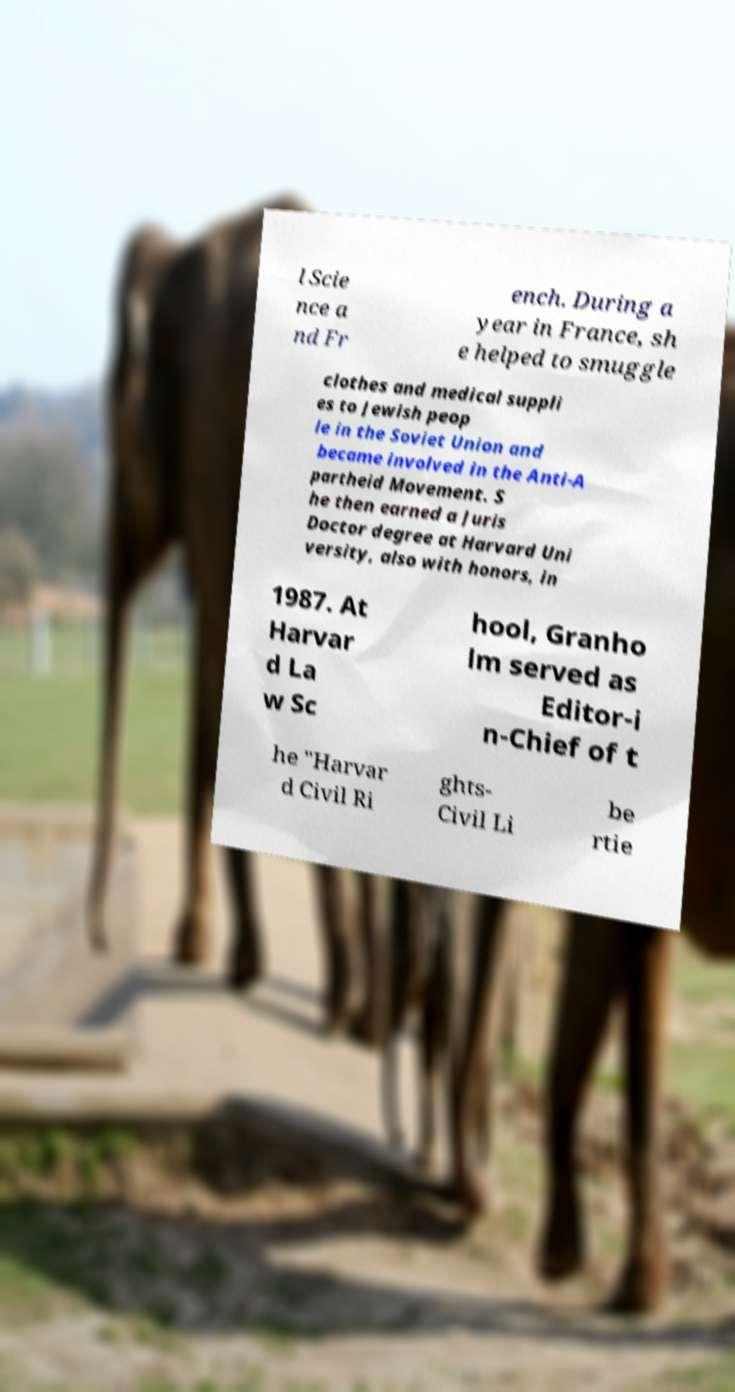For documentation purposes, I need the text within this image transcribed. Could you provide that? l Scie nce a nd Fr ench. During a year in France, sh e helped to smuggle clothes and medical suppli es to Jewish peop le in the Soviet Union and became involved in the Anti-A partheid Movement. S he then earned a Juris Doctor degree at Harvard Uni versity, also with honors, in 1987. At Harvar d La w Sc hool, Granho lm served as Editor-i n-Chief of t he "Harvar d Civil Ri ghts- Civil Li be rtie 